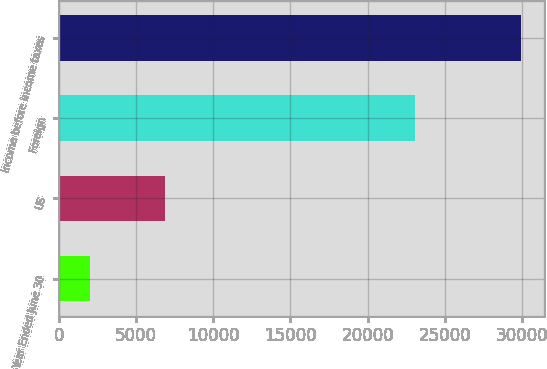<chart> <loc_0><loc_0><loc_500><loc_500><bar_chart><fcel>Year Ended June 30<fcel>US<fcel>Foreign<fcel>Income before income taxes<nl><fcel>2017<fcel>6843<fcel>23058<fcel>29901<nl></chart> 